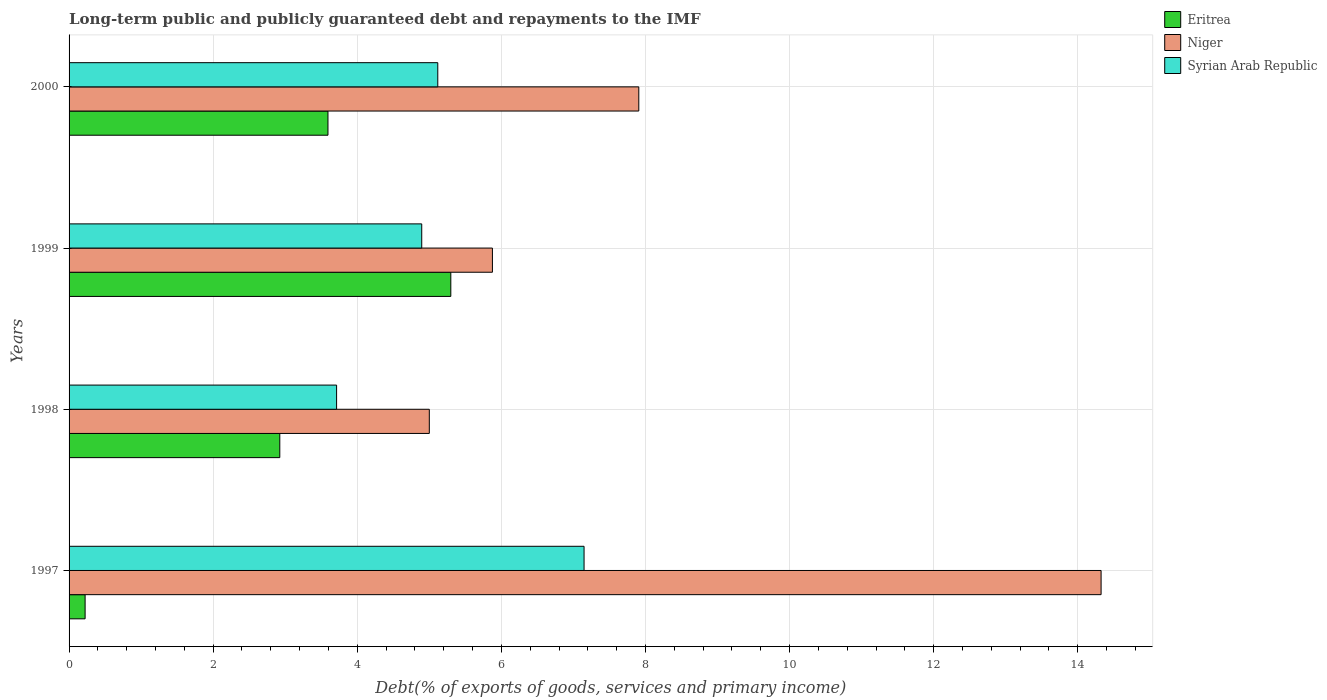Are the number of bars on each tick of the Y-axis equal?
Offer a very short reply. Yes. How many bars are there on the 4th tick from the top?
Give a very brief answer. 3. What is the label of the 2nd group of bars from the top?
Provide a short and direct response. 1999. What is the debt and repayments in Syrian Arab Republic in 1997?
Keep it short and to the point. 7.15. Across all years, what is the maximum debt and repayments in Syrian Arab Republic?
Offer a terse response. 7.15. Across all years, what is the minimum debt and repayments in Niger?
Provide a succinct answer. 5. In which year was the debt and repayments in Niger maximum?
Provide a short and direct response. 1997. In which year was the debt and repayments in Syrian Arab Republic minimum?
Your answer should be compact. 1998. What is the total debt and repayments in Syrian Arab Republic in the graph?
Your answer should be very brief. 20.87. What is the difference between the debt and repayments in Syrian Arab Republic in 1997 and that in 1999?
Give a very brief answer. 2.25. What is the difference between the debt and repayments in Niger in 1997 and the debt and repayments in Syrian Arab Republic in 1999?
Provide a succinct answer. 9.43. What is the average debt and repayments in Niger per year?
Your response must be concise. 8.28. In the year 2000, what is the difference between the debt and repayments in Syrian Arab Republic and debt and repayments in Niger?
Provide a succinct answer. -2.79. What is the ratio of the debt and repayments in Niger in 1999 to that in 2000?
Your answer should be very brief. 0.74. Is the debt and repayments in Syrian Arab Republic in 1998 less than that in 2000?
Keep it short and to the point. Yes. What is the difference between the highest and the second highest debt and repayments in Eritrea?
Offer a very short reply. 1.7. What is the difference between the highest and the lowest debt and repayments in Syrian Arab Republic?
Offer a very short reply. 3.43. In how many years, is the debt and repayments in Eritrea greater than the average debt and repayments in Eritrea taken over all years?
Your answer should be very brief. 2. Is the sum of the debt and repayments in Niger in 1999 and 2000 greater than the maximum debt and repayments in Syrian Arab Republic across all years?
Ensure brevity in your answer.  Yes. What does the 3rd bar from the top in 1998 represents?
Ensure brevity in your answer.  Eritrea. What does the 2nd bar from the bottom in 1997 represents?
Your answer should be compact. Niger. Is it the case that in every year, the sum of the debt and repayments in Syrian Arab Republic and debt and repayments in Eritrea is greater than the debt and repayments in Niger?
Your answer should be compact. No. How many bars are there?
Offer a terse response. 12. How many years are there in the graph?
Your response must be concise. 4. Are the values on the major ticks of X-axis written in scientific E-notation?
Provide a succinct answer. No. Does the graph contain grids?
Provide a short and direct response. Yes. How many legend labels are there?
Keep it short and to the point. 3. What is the title of the graph?
Offer a very short reply. Long-term public and publicly guaranteed debt and repayments to the IMF. Does "Brunei Darussalam" appear as one of the legend labels in the graph?
Your answer should be compact. No. What is the label or title of the X-axis?
Offer a very short reply. Debt(% of exports of goods, services and primary income). What is the Debt(% of exports of goods, services and primary income) in Eritrea in 1997?
Offer a very short reply. 0.22. What is the Debt(% of exports of goods, services and primary income) of Niger in 1997?
Your response must be concise. 14.32. What is the Debt(% of exports of goods, services and primary income) in Syrian Arab Republic in 1997?
Make the answer very short. 7.15. What is the Debt(% of exports of goods, services and primary income) of Eritrea in 1998?
Your response must be concise. 2.92. What is the Debt(% of exports of goods, services and primary income) of Niger in 1998?
Provide a succinct answer. 5. What is the Debt(% of exports of goods, services and primary income) of Syrian Arab Republic in 1998?
Ensure brevity in your answer.  3.71. What is the Debt(% of exports of goods, services and primary income) of Eritrea in 1999?
Make the answer very short. 5.3. What is the Debt(% of exports of goods, services and primary income) in Niger in 1999?
Offer a very short reply. 5.88. What is the Debt(% of exports of goods, services and primary income) in Syrian Arab Republic in 1999?
Offer a very short reply. 4.89. What is the Debt(% of exports of goods, services and primary income) in Eritrea in 2000?
Your answer should be compact. 3.59. What is the Debt(% of exports of goods, services and primary income) in Niger in 2000?
Provide a succinct answer. 7.91. What is the Debt(% of exports of goods, services and primary income) of Syrian Arab Republic in 2000?
Your answer should be very brief. 5.12. Across all years, what is the maximum Debt(% of exports of goods, services and primary income) in Eritrea?
Keep it short and to the point. 5.3. Across all years, what is the maximum Debt(% of exports of goods, services and primary income) in Niger?
Your answer should be compact. 14.32. Across all years, what is the maximum Debt(% of exports of goods, services and primary income) of Syrian Arab Republic?
Give a very brief answer. 7.15. Across all years, what is the minimum Debt(% of exports of goods, services and primary income) of Eritrea?
Provide a short and direct response. 0.22. Across all years, what is the minimum Debt(% of exports of goods, services and primary income) in Syrian Arab Republic?
Provide a short and direct response. 3.71. What is the total Debt(% of exports of goods, services and primary income) of Eritrea in the graph?
Provide a succinct answer. 12.04. What is the total Debt(% of exports of goods, services and primary income) of Niger in the graph?
Make the answer very short. 33.11. What is the total Debt(% of exports of goods, services and primary income) in Syrian Arab Republic in the graph?
Your response must be concise. 20.87. What is the difference between the Debt(% of exports of goods, services and primary income) in Eritrea in 1997 and that in 1998?
Provide a short and direct response. -2.7. What is the difference between the Debt(% of exports of goods, services and primary income) of Niger in 1997 and that in 1998?
Ensure brevity in your answer.  9.32. What is the difference between the Debt(% of exports of goods, services and primary income) of Syrian Arab Republic in 1997 and that in 1998?
Keep it short and to the point. 3.43. What is the difference between the Debt(% of exports of goods, services and primary income) in Eritrea in 1997 and that in 1999?
Your answer should be very brief. -5.08. What is the difference between the Debt(% of exports of goods, services and primary income) of Niger in 1997 and that in 1999?
Offer a very short reply. 8.45. What is the difference between the Debt(% of exports of goods, services and primary income) in Syrian Arab Republic in 1997 and that in 1999?
Provide a short and direct response. 2.25. What is the difference between the Debt(% of exports of goods, services and primary income) of Eritrea in 1997 and that in 2000?
Ensure brevity in your answer.  -3.37. What is the difference between the Debt(% of exports of goods, services and primary income) of Niger in 1997 and that in 2000?
Your answer should be compact. 6.42. What is the difference between the Debt(% of exports of goods, services and primary income) in Syrian Arab Republic in 1997 and that in 2000?
Your answer should be compact. 2.03. What is the difference between the Debt(% of exports of goods, services and primary income) in Eritrea in 1998 and that in 1999?
Provide a succinct answer. -2.37. What is the difference between the Debt(% of exports of goods, services and primary income) of Niger in 1998 and that in 1999?
Keep it short and to the point. -0.88. What is the difference between the Debt(% of exports of goods, services and primary income) of Syrian Arab Republic in 1998 and that in 1999?
Ensure brevity in your answer.  -1.18. What is the difference between the Debt(% of exports of goods, services and primary income) in Eritrea in 1998 and that in 2000?
Offer a terse response. -0.67. What is the difference between the Debt(% of exports of goods, services and primary income) in Niger in 1998 and that in 2000?
Your answer should be very brief. -2.91. What is the difference between the Debt(% of exports of goods, services and primary income) of Syrian Arab Republic in 1998 and that in 2000?
Make the answer very short. -1.4. What is the difference between the Debt(% of exports of goods, services and primary income) of Eritrea in 1999 and that in 2000?
Keep it short and to the point. 1.7. What is the difference between the Debt(% of exports of goods, services and primary income) of Niger in 1999 and that in 2000?
Offer a terse response. -2.03. What is the difference between the Debt(% of exports of goods, services and primary income) in Syrian Arab Republic in 1999 and that in 2000?
Offer a very short reply. -0.22. What is the difference between the Debt(% of exports of goods, services and primary income) in Eritrea in 1997 and the Debt(% of exports of goods, services and primary income) in Niger in 1998?
Provide a succinct answer. -4.78. What is the difference between the Debt(% of exports of goods, services and primary income) in Eritrea in 1997 and the Debt(% of exports of goods, services and primary income) in Syrian Arab Republic in 1998?
Your response must be concise. -3.49. What is the difference between the Debt(% of exports of goods, services and primary income) in Niger in 1997 and the Debt(% of exports of goods, services and primary income) in Syrian Arab Republic in 1998?
Offer a terse response. 10.61. What is the difference between the Debt(% of exports of goods, services and primary income) in Eritrea in 1997 and the Debt(% of exports of goods, services and primary income) in Niger in 1999?
Keep it short and to the point. -5.65. What is the difference between the Debt(% of exports of goods, services and primary income) in Eritrea in 1997 and the Debt(% of exports of goods, services and primary income) in Syrian Arab Republic in 1999?
Provide a succinct answer. -4.67. What is the difference between the Debt(% of exports of goods, services and primary income) of Niger in 1997 and the Debt(% of exports of goods, services and primary income) of Syrian Arab Republic in 1999?
Provide a short and direct response. 9.43. What is the difference between the Debt(% of exports of goods, services and primary income) of Eritrea in 1997 and the Debt(% of exports of goods, services and primary income) of Niger in 2000?
Provide a short and direct response. -7.68. What is the difference between the Debt(% of exports of goods, services and primary income) in Eritrea in 1997 and the Debt(% of exports of goods, services and primary income) in Syrian Arab Republic in 2000?
Offer a very short reply. -4.89. What is the difference between the Debt(% of exports of goods, services and primary income) in Niger in 1997 and the Debt(% of exports of goods, services and primary income) in Syrian Arab Republic in 2000?
Offer a terse response. 9.21. What is the difference between the Debt(% of exports of goods, services and primary income) of Eritrea in 1998 and the Debt(% of exports of goods, services and primary income) of Niger in 1999?
Your answer should be compact. -2.95. What is the difference between the Debt(% of exports of goods, services and primary income) in Eritrea in 1998 and the Debt(% of exports of goods, services and primary income) in Syrian Arab Republic in 1999?
Offer a terse response. -1.97. What is the difference between the Debt(% of exports of goods, services and primary income) in Niger in 1998 and the Debt(% of exports of goods, services and primary income) in Syrian Arab Republic in 1999?
Make the answer very short. 0.11. What is the difference between the Debt(% of exports of goods, services and primary income) of Eritrea in 1998 and the Debt(% of exports of goods, services and primary income) of Niger in 2000?
Your response must be concise. -4.98. What is the difference between the Debt(% of exports of goods, services and primary income) in Eritrea in 1998 and the Debt(% of exports of goods, services and primary income) in Syrian Arab Republic in 2000?
Your response must be concise. -2.19. What is the difference between the Debt(% of exports of goods, services and primary income) in Niger in 1998 and the Debt(% of exports of goods, services and primary income) in Syrian Arab Republic in 2000?
Provide a short and direct response. -0.12. What is the difference between the Debt(% of exports of goods, services and primary income) of Eritrea in 1999 and the Debt(% of exports of goods, services and primary income) of Niger in 2000?
Your answer should be compact. -2.61. What is the difference between the Debt(% of exports of goods, services and primary income) of Eritrea in 1999 and the Debt(% of exports of goods, services and primary income) of Syrian Arab Republic in 2000?
Provide a short and direct response. 0.18. What is the difference between the Debt(% of exports of goods, services and primary income) of Niger in 1999 and the Debt(% of exports of goods, services and primary income) of Syrian Arab Republic in 2000?
Ensure brevity in your answer.  0.76. What is the average Debt(% of exports of goods, services and primary income) in Eritrea per year?
Provide a short and direct response. 3.01. What is the average Debt(% of exports of goods, services and primary income) of Niger per year?
Ensure brevity in your answer.  8.28. What is the average Debt(% of exports of goods, services and primary income) in Syrian Arab Republic per year?
Offer a very short reply. 5.22. In the year 1997, what is the difference between the Debt(% of exports of goods, services and primary income) in Eritrea and Debt(% of exports of goods, services and primary income) in Niger?
Offer a terse response. -14.1. In the year 1997, what is the difference between the Debt(% of exports of goods, services and primary income) of Eritrea and Debt(% of exports of goods, services and primary income) of Syrian Arab Republic?
Make the answer very short. -6.93. In the year 1997, what is the difference between the Debt(% of exports of goods, services and primary income) of Niger and Debt(% of exports of goods, services and primary income) of Syrian Arab Republic?
Make the answer very short. 7.18. In the year 1998, what is the difference between the Debt(% of exports of goods, services and primary income) in Eritrea and Debt(% of exports of goods, services and primary income) in Niger?
Provide a succinct answer. -2.08. In the year 1998, what is the difference between the Debt(% of exports of goods, services and primary income) in Eritrea and Debt(% of exports of goods, services and primary income) in Syrian Arab Republic?
Offer a very short reply. -0.79. In the year 1998, what is the difference between the Debt(% of exports of goods, services and primary income) of Niger and Debt(% of exports of goods, services and primary income) of Syrian Arab Republic?
Provide a succinct answer. 1.29. In the year 1999, what is the difference between the Debt(% of exports of goods, services and primary income) in Eritrea and Debt(% of exports of goods, services and primary income) in Niger?
Offer a very short reply. -0.58. In the year 1999, what is the difference between the Debt(% of exports of goods, services and primary income) of Eritrea and Debt(% of exports of goods, services and primary income) of Syrian Arab Republic?
Keep it short and to the point. 0.4. In the year 1999, what is the difference between the Debt(% of exports of goods, services and primary income) in Niger and Debt(% of exports of goods, services and primary income) in Syrian Arab Republic?
Offer a very short reply. 0.98. In the year 2000, what is the difference between the Debt(% of exports of goods, services and primary income) in Eritrea and Debt(% of exports of goods, services and primary income) in Niger?
Ensure brevity in your answer.  -4.31. In the year 2000, what is the difference between the Debt(% of exports of goods, services and primary income) of Eritrea and Debt(% of exports of goods, services and primary income) of Syrian Arab Republic?
Make the answer very short. -1.52. In the year 2000, what is the difference between the Debt(% of exports of goods, services and primary income) of Niger and Debt(% of exports of goods, services and primary income) of Syrian Arab Republic?
Ensure brevity in your answer.  2.79. What is the ratio of the Debt(% of exports of goods, services and primary income) in Eritrea in 1997 to that in 1998?
Make the answer very short. 0.08. What is the ratio of the Debt(% of exports of goods, services and primary income) of Niger in 1997 to that in 1998?
Keep it short and to the point. 2.86. What is the ratio of the Debt(% of exports of goods, services and primary income) of Syrian Arab Republic in 1997 to that in 1998?
Provide a short and direct response. 1.93. What is the ratio of the Debt(% of exports of goods, services and primary income) in Eritrea in 1997 to that in 1999?
Ensure brevity in your answer.  0.04. What is the ratio of the Debt(% of exports of goods, services and primary income) in Niger in 1997 to that in 1999?
Provide a short and direct response. 2.44. What is the ratio of the Debt(% of exports of goods, services and primary income) of Syrian Arab Republic in 1997 to that in 1999?
Offer a terse response. 1.46. What is the ratio of the Debt(% of exports of goods, services and primary income) of Eritrea in 1997 to that in 2000?
Ensure brevity in your answer.  0.06. What is the ratio of the Debt(% of exports of goods, services and primary income) of Niger in 1997 to that in 2000?
Give a very brief answer. 1.81. What is the ratio of the Debt(% of exports of goods, services and primary income) in Syrian Arab Republic in 1997 to that in 2000?
Make the answer very short. 1.4. What is the ratio of the Debt(% of exports of goods, services and primary income) in Eritrea in 1998 to that in 1999?
Your response must be concise. 0.55. What is the ratio of the Debt(% of exports of goods, services and primary income) of Niger in 1998 to that in 1999?
Your response must be concise. 0.85. What is the ratio of the Debt(% of exports of goods, services and primary income) in Syrian Arab Republic in 1998 to that in 1999?
Your answer should be compact. 0.76. What is the ratio of the Debt(% of exports of goods, services and primary income) in Eritrea in 1998 to that in 2000?
Provide a succinct answer. 0.81. What is the ratio of the Debt(% of exports of goods, services and primary income) of Niger in 1998 to that in 2000?
Make the answer very short. 0.63. What is the ratio of the Debt(% of exports of goods, services and primary income) of Syrian Arab Republic in 1998 to that in 2000?
Offer a very short reply. 0.73. What is the ratio of the Debt(% of exports of goods, services and primary income) of Eritrea in 1999 to that in 2000?
Your answer should be very brief. 1.47. What is the ratio of the Debt(% of exports of goods, services and primary income) in Niger in 1999 to that in 2000?
Make the answer very short. 0.74. What is the ratio of the Debt(% of exports of goods, services and primary income) in Syrian Arab Republic in 1999 to that in 2000?
Keep it short and to the point. 0.96. What is the difference between the highest and the second highest Debt(% of exports of goods, services and primary income) in Eritrea?
Provide a short and direct response. 1.7. What is the difference between the highest and the second highest Debt(% of exports of goods, services and primary income) of Niger?
Offer a terse response. 6.42. What is the difference between the highest and the second highest Debt(% of exports of goods, services and primary income) of Syrian Arab Republic?
Make the answer very short. 2.03. What is the difference between the highest and the lowest Debt(% of exports of goods, services and primary income) in Eritrea?
Ensure brevity in your answer.  5.08. What is the difference between the highest and the lowest Debt(% of exports of goods, services and primary income) in Niger?
Make the answer very short. 9.32. What is the difference between the highest and the lowest Debt(% of exports of goods, services and primary income) of Syrian Arab Republic?
Your response must be concise. 3.43. 